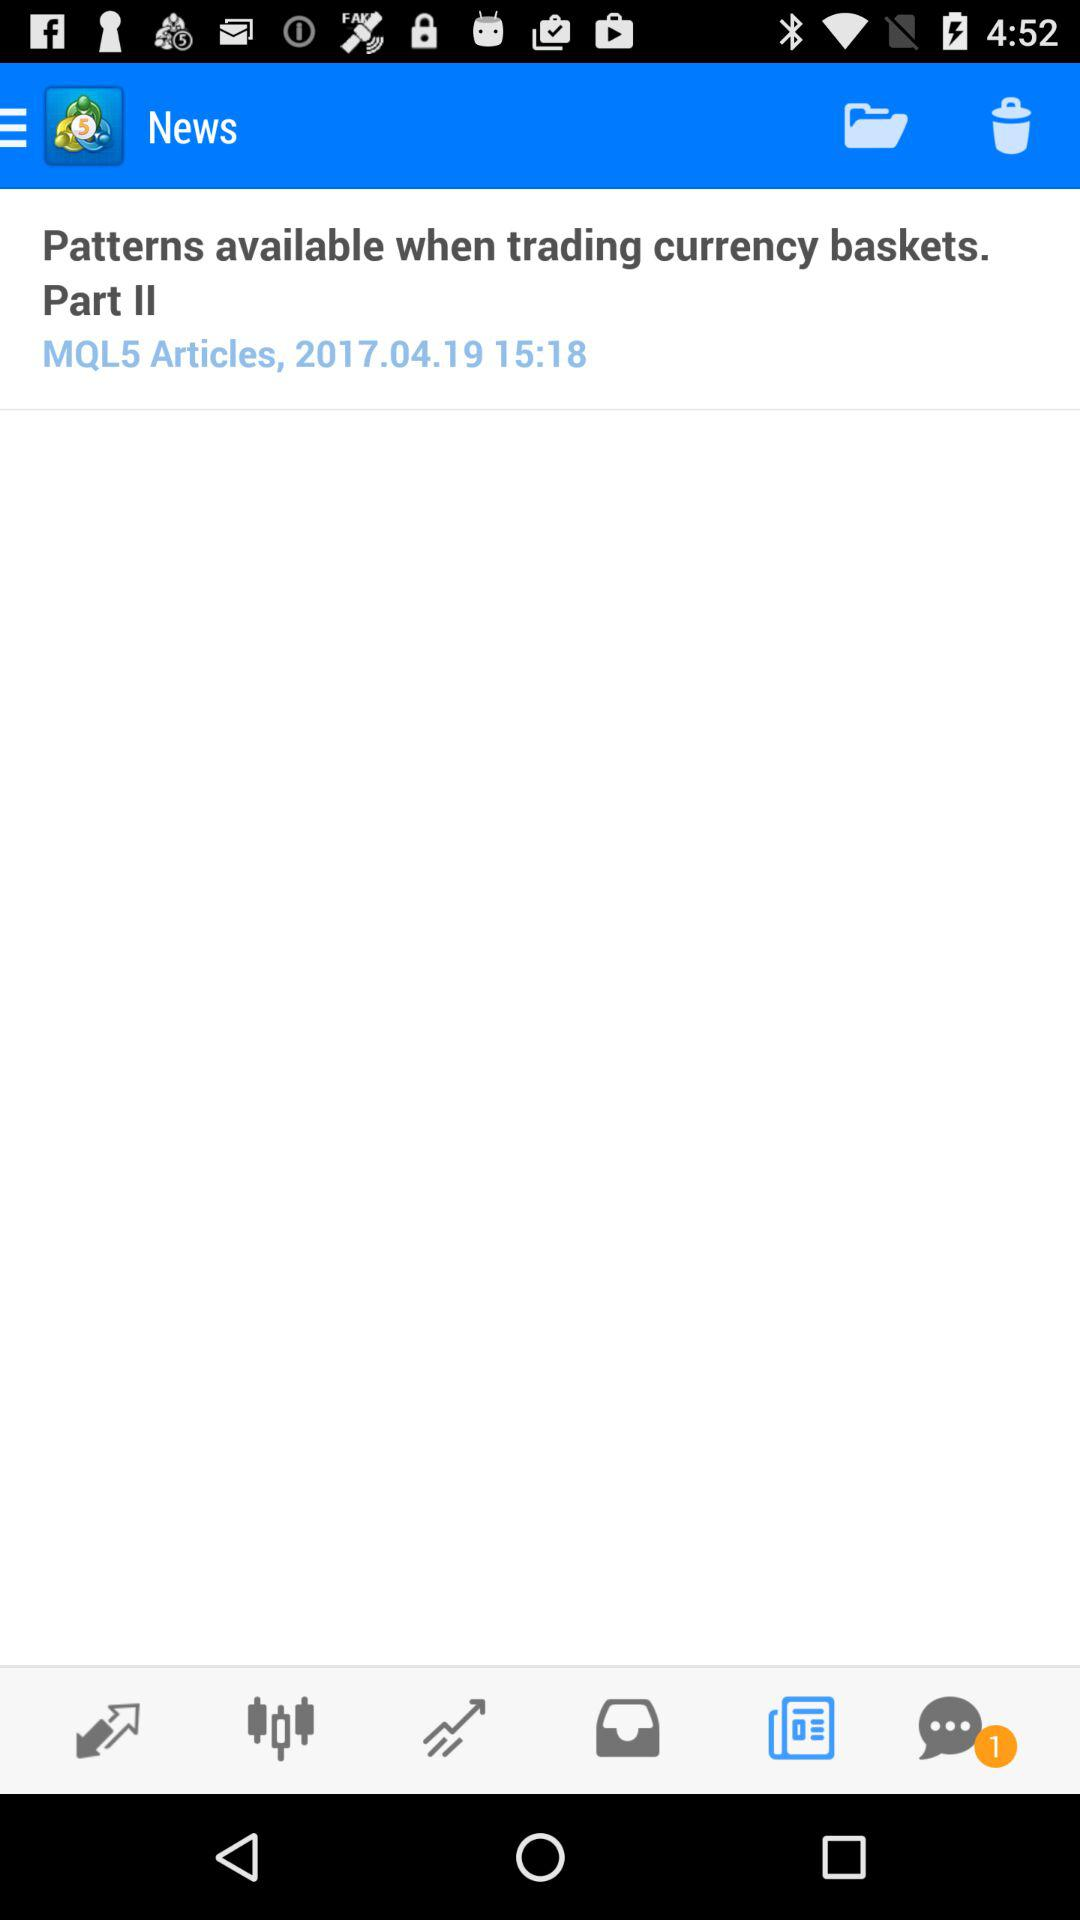What is the date of the article? The date is April 19, 2017. 